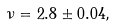Convert formula to latex. <formula><loc_0><loc_0><loc_500><loc_500>\nu = 2 . 8 \pm 0 . 0 4 ,</formula> 